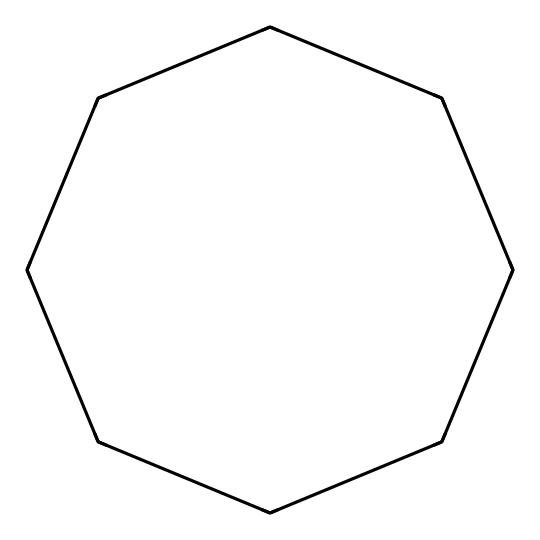How many carbon atoms are in cyclooctane? The SMILES notation "C1CCCCCCC1" indicates a cyclic structure, where the "C" represents carbon atoms. Counting these, we see there are 8 carbon atoms.
Answer: 8 What type of chemical structure does cyclooctane represent? The structure indicates a cyclic arrangement of carbon atoms bonded to each other, which defines cycloalkanes.
Answer: cycloalkane How many hydrogen atoms are there in cyclooctane? Each carbon atom in cycloalkanes is typically bonded to enough hydrogen atoms to satisfy the tetravalence of carbon. For cyclooctane, with 8 carbons, the formula CnH2n corresponds to C8H16. Thus, there are 16 hydrogen atoms.
Answer: 16 What is the significance of the ring structure in cyclooctane for lubricants? The ring structure provides stability and lower volatility compared to linear hydrocarbons, which is beneficial in lubrication applications for reducing evaporation and maintaining viscosity.
Answer: stability How does cyclooctane's structure affect its viscosity compared to linear alkanes? Cyclooctane's cyclic structure creates a more compact molecule than linear alkanes, resulting in higher intermolecular interactions and thus higher viscosity at a given temperature compared to linear counterparts.
Answer: higher viscosity What is the boiling point range of cyclooctane? Cyclooctane has a boiling point of approximately 147 degrees Celsius, which indicates its effectiveness as a lubricant for high-temperature applications in transportation equipment.
Answer: 147 degrees Celsius 